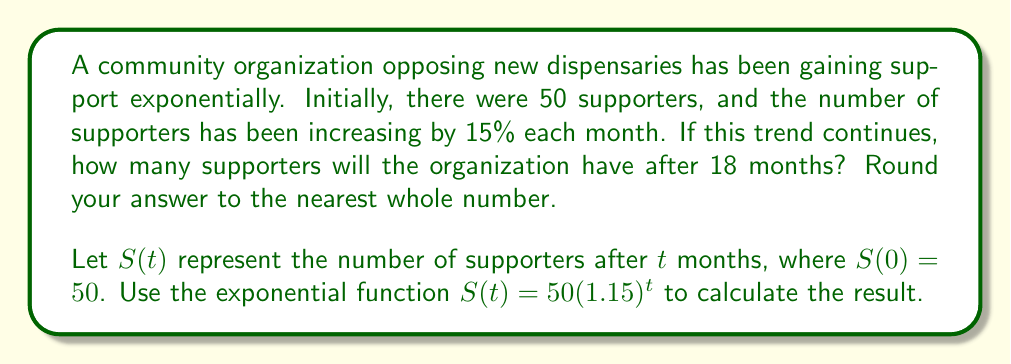Teach me how to tackle this problem. To solve this problem, we'll use the exponential growth function:

$S(t) = S_0 \cdot (1 + r)^t$

Where:
$S(t)$ is the number of supporters after $t$ months
$S_0$ is the initial number of supporters
$r$ is the growth rate (as a decimal)
$t$ is the time in months

Given:
$S_0 = 50$ (initial supporters)
$r = 0.15$ (15% growth rate)
$t = 18$ months

Let's substitute these values into the equation:

$S(18) = 50 \cdot (1 + 0.15)^{18}$

$S(18) = 50 \cdot (1.15)^{18}$

Now, let's calculate:

$S(18) = 50 \cdot 13.0069...$ (using a calculator)

$S(18) = 650.3467...$

Rounding to the nearest whole number:

$S(18) \approx 650$ supporters
Answer: 650 supporters 